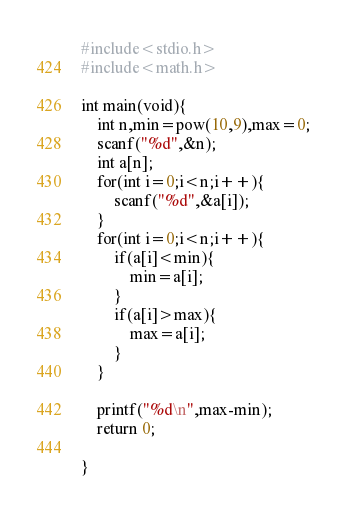Convert code to text. <code><loc_0><loc_0><loc_500><loc_500><_C_>#include<stdio.h>
#include<math.h>

int main(void){
    int n,min=pow(10,9),max=0;
    scanf("%d",&n);
    int a[n];
    for(int i=0;i<n;i++){
        scanf("%d",&a[i]);
    }
    for(int i=0;i<n;i++){
        if(a[i]<min){
            min=a[i];
        }
        if(a[i]>max){
            max=a[i];
        }
    }

    printf("%d\n",max-min);
    return 0;

}</code> 